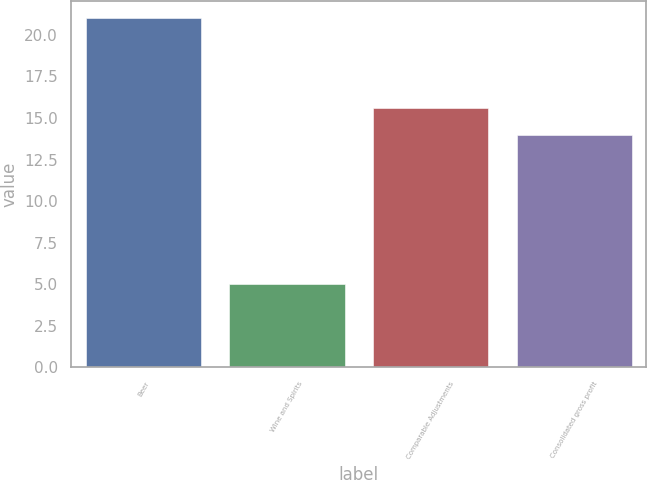Convert chart to OTSL. <chart><loc_0><loc_0><loc_500><loc_500><bar_chart><fcel>Beer<fcel>Wine and Spirits<fcel>Comparable Adjustments<fcel>Consolidated gross profit<nl><fcel>21<fcel>5<fcel>15.6<fcel>14<nl></chart> 